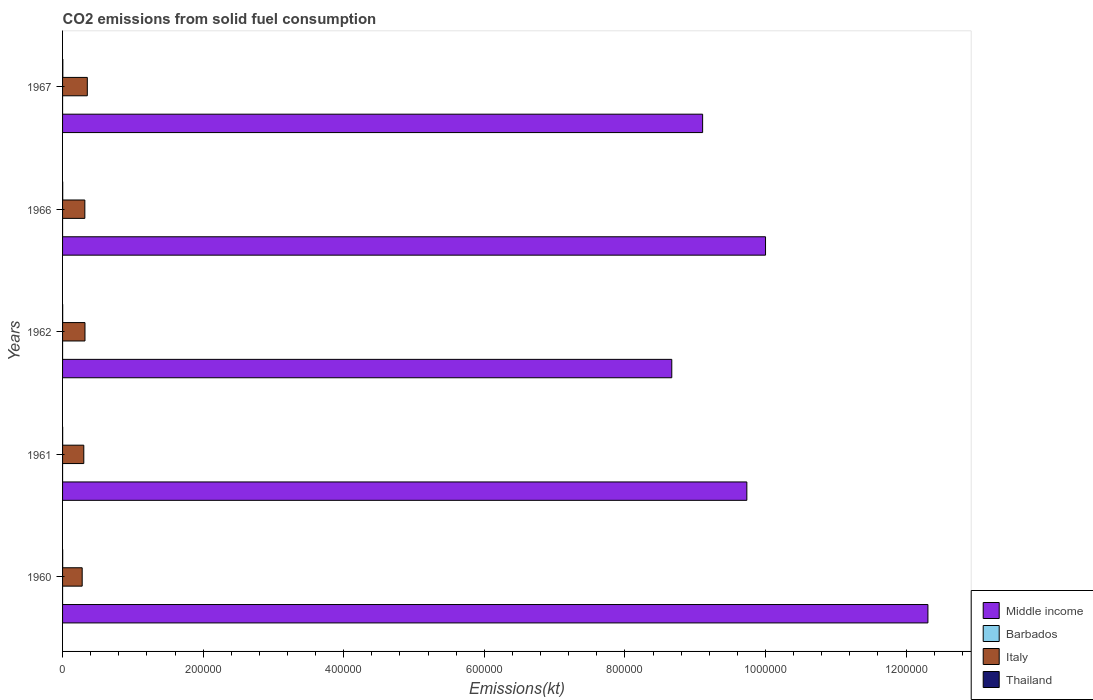How many different coloured bars are there?
Your answer should be compact. 4. Are the number of bars per tick equal to the number of legend labels?
Provide a succinct answer. Yes. Are the number of bars on each tick of the Y-axis equal?
Your answer should be compact. Yes. How many bars are there on the 5th tick from the bottom?
Provide a short and direct response. 4. In how many cases, is the number of bars for a given year not equal to the number of legend labels?
Provide a succinct answer. 0. What is the amount of CO2 emitted in Barbados in 1961?
Provide a succinct answer. 3.67. Across all years, what is the maximum amount of CO2 emitted in Italy?
Your answer should be very brief. 3.52e+04. Across all years, what is the minimum amount of CO2 emitted in Barbados?
Your answer should be very brief. 3.67. In which year was the amount of CO2 emitted in Thailand maximum?
Your answer should be very brief. 1967. In which year was the amount of CO2 emitted in Thailand minimum?
Your answer should be compact. 1961. What is the total amount of CO2 emitted in Middle income in the graph?
Offer a terse response. 4.98e+06. What is the difference between the amount of CO2 emitted in Italy in 1962 and that in 1966?
Make the answer very short. 201.69. What is the difference between the amount of CO2 emitted in Barbados in 1966 and the amount of CO2 emitted in Thailand in 1961?
Provide a short and direct response. -117.34. What is the average amount of CO2 emitted in Italy per year?
Your answer should be compact. 3.14e+04. In the year 1967, what is the difference between the amount of CO2 emitted in Middle income and amount of CO2 emitted in Thailand?
Your answer should be very brief. 9.10e+05. What is the ratio of the amount of CO2 emitted in Thailand in 1962 to that in 1966?
Offer a very short reply. 0.77. Is the amount of CO2 emitted in Middle income in 1961 less than that in 1966?
Keep it short and to the point. Yes. Is the difference between the amount of CO2 emitted in Middle income in 1961 and 1962 greater than the difference between the amount of CO2 emitted in Thailand in 1961 and 1962?
Ensure brevity in your answer.  Yes. What is the difference between the highest and the second highest amount of CO2 emitted in Italy?
Make the answer very short. 3311.3. What is the difference between the highest and the lowest amount of CO2 emitted in Middle income?
Your response must be concise. 3.64e+05. In how many years, is the amount of CO2 emitted in Barbados greater than the average amount of CO2 emitted in Barbados taken over all years?
Your answer should be compact. 0. Is the sum of the amount of CO2 emitted in Italy in 1960 and 1966 greater than the maximum amount of CO2 emitted in Barbados across all years?
Give a very brief answer. Yes. Is it the case that in every year, the sum of the amount of CO2 emitted in Barbados and amount of CO2 emitted in Thailand is greater than the sum of amount of CO2 emitted in Italy and amount of CO2 emitted in Middle income?
Your response must be concise. No. What does the 3rd bar from the top in 1960 represents?
Your answer should be compact. Barbados. What does the 4th bar from the bottom in 1967 represents?
Offer a very short reply. Thailand. Is it the case that in every year, the sum of the amount of CO2 emitted in Italy and amount of CO2 emitted in Middle income is greater than the amount of CO2 emitted in Barbados?
Ensure brevity in your answer.  Yes. Are the values on the major ticks of X-axis written in scientific E-notation?
Provide a succinct answer. No. Does the graph contain grids?
Offer a terse response. No. Where does the legend appear in the graph?
Give a very brief answer. Bottom right. How many legend labels are there?
Ensure brevity in your answer.  4. What is the title of the graph?
Offer a terse response. CO2 emissions from solid fuel consumption. Does "Central Europe" appear as one of the legend labels in the graph?
Offer a terse response. No. What is the label or title of the X-axis?
Give a very brief answer. Emissions(kt). What is the Emissions(kt) of Middle income in 1960?
Your answer should be very brief. 1.23e+06. What is the Emissions(kt) in Barbados in 1960?
Provide a short and direct response. 3.67. What is the Emissions(kt) in Italy in 1960?
Offer a terse response. 2.79e+04. What is the Emissions(kt) in Thailand in 1960?
Ensure brevity in your answer.  146.68. What is the Emissions(kt) of Middle income in 1961?
Offer a terse response. 9.74e+05. What is the Emissions(kt) of Barbados in 1961?
Keep it short and to the point. 3.67. What is the Emissions(kt) in Italy in 1961?
Provide a succinct answer. 3.02e+04. What is the Emissions(kt) in Thailand in 1961?
Offer a very short reply. 121.01. What is the Emissions(kt) of Middle income in 1962?
Keep it short and to the point. 8.67e+05. What is the Emissions(kt) in Barbados in 1962?
Make the answer very short. 3.67. What is the Emissions(kt) in Italy in 1962?
Your answer should be very brief. 3.19e+04. What is the Emissions(kt) of Thailand in 1962?
Offer a terse response. 150.35. What is the Emissions(kt) of Middle income in 1966?
Keep it short and to the point. 1.00e+06. What is the Emissions(kt) of Barbados in 1966?
Your response must be concise. 3.67. What is the Emissions(kt) in Italy in 1966?
Keep it short and to the point. 3.17e+04. What is the Emissions(kt) in Thailand in 1966?
Offer a terse response. 194.35. What is the Emissions(kt) of Middle income in 1967?
Ensure brevity in your answer.  9.11e+05. What is the Emissions(kt) of Barbados in 1967?
Your answer should be compact. 3.67. What is the Emissions(kt) of Italy in 1967?
Your answer should be compact. 3.52e+04. What is the Emissions(kt) of Thailand in 1967?
Offer a very short reply. 374.03. Across all years, what is the maximum Emissions(kt) of Middle income?
Provide a short and direct response. 1.23e+06. Across all years, what is the maximum Emissions(kt) in Barbados?
Keep it short and to the point. 3.67. Across all years, what is the maximum Emissions(kt) of Italy?
Your response must be concise. 3.52e+04. Across all years, what is the maximum Emissions(kt) in Thailand?
Make the answer very short. 374.03. Across all years, what is the minimum Emissions(kt) in Middle income?
Offer a terse response. 8.67e+05. Across all years, what is the minimum Emissions(kt) of Barbados?
Offer a terse response. 3.67. Across all years, what is the minimum Emissions(kt) of Italy?
Offer a terse response. 2.79e+04. Across all years, what is the minimum Emissions(kt) of Thailand?
Make the answer very short. 121.01. What is the total Emissions(kt) of Middle income in the graph?
Provide a succinct answer. 4.98e+06. What is the total Emissions(kt) of Barbados in the graph?
Provide a short and direct response. 18.34. What is the total Emissions(kt) of Italy in the graph?
Make the answer very short. 1.57e+05. What is the total Emissions(kt) of Thailand in the graph?
Keep it short and to the point. 986.42. What is the difference between the Emissions(kt) of Middle income in 1960 and that in 1961?
Your answer should be compact. 2.58e+05. What is the difference between the Emissions(kt) in Italy in 1960 and that in 1961?
Provide a short and direct response. -2288.21. What is the difference between the Emissions(kt) of Thailand in 1960 and that in 1961?
Your answer should be very brief. 25.67. What is the difference between the Emissions(kt) in Middle income in 1960 and that in 1962?
Your answer should be compact. 3.64e+05. What is the difference between the Emissions(kt) of Barbados in 1960 and that in 1962?
Your response must be concise. 0. What is the difference between the Emissions(kt) of Italy in 1960 and that in 1962?
Give a very brief answer. -3993.36. What is the difference between the Emissions(kt) of Thailand in 1960 and that in 1962?
Your response must be concise. -3.67. What is the difference between the Emissions(kt) of Middle income in 1960 and that in 1966?
Offer a terse response. 2.31e+05. What is the difference between the Emissions(kt) of Barbados in 1960 and that in 1966?
Your answer should be very brief. 0. What is the difference between the Emissions(kt) in Italy in 1960 and that in 1966?
Offer a terse response. -3791.68. What is the difference between the Emissions(kt) of Thailand in 1960 and that in 1966?
Your answer should be compact. -47.67. What is the difference between the Emissions(kt) in Middle income in 1960 and that in 1967?
Provide a succinct answer. 3.21e+05. What is the difference between the Emissions(kt) in Barbados in 1960 and that in 1967?
Your response must be concise. 0. What is the difference between the Emissions(kt) in Italy in 1960 and that in 1967?
Ensure brevity in your answer.  -7304.66. What is the difference between the Emissions(kt) in Thailand in 1960 and that in 1967?
Your answer should be very brief. -227.35. What is the difference between the Emissions(kt) of Middle income in 1961 and that in 1962?
Your response must be concise. 1.07e+05. What is the difference between the Emissions(kt) of Italy in 1961 and that in 1962?
Keep it short and to the point. -1705.15. What is the difference between the Emissions(kt) of Thailand in 1961 and that in 1962?
Ensure brevity in your answer.  -29.34. What is the difference between the Emissions(kt) of Middle income in 1961 and that in 1966?
Ensure brevity in your answer.  -2.66e+04. What is the difference between the Emissions(kt) of Barbados in 1961 and that in 1966?
Ensure brevity in your answer.  0. What is the difference between the Emissions(kt) in Italy in 1961 and that in 1966?
Ensure brevity in your answer.  -1503.47. What is the difference between the Emissions(kt) in Thailand in 1961 and that in 1966?
Provide a short and direct response. -73.34. What is the difference between the Emissions(kt) in Middle income in 1961 and that in 1967?
Provide a succinct answer. 6.29e+04. What is the difference between the Emissions(kt) in Barbados in 1961 and that in 1967?
Provide a short and direct response. 0. What is the difference between the Emissions(kt) in Italy in 1961 and that in 1967?
Your answer should be very brief. -5016.46. What is the difference between the Emissions(kt) of Thailand in 1961 and that in 1967?
Make the answer very short. -253.02. What is the difference between the Emissions(kt) in Middle income in 1962 and that in 1966?
Give a very brief answer. -1.33e+05. What is the difference between the Emissions(kt) of Italy in 1962 and that in 1966?
Offer a terse response. 201.69. What is the difference between the Emissions(kt) of Thailand in 1962 and that in 1966?
Provide a short and direct response. -44. What is the difference between the Emissions(kt) of Middle income in 1962 and that in 1967?
Your response must be concise. -4.39e+04. What is the difference between the Emissions(kt) in Barbados in 1962 and that in 1967?
Offer a terse response. 0. What is the difference between the Emissions(kt) of Italy in 1962 and that in 1967?
Your answer should be very brief. -3311.3. What is the difference between the Emissions(kt) in Thailand in 1962 and that in 1967?
Give a very brief answer. -223.69. What is the difference between the Emissions(kt) of Middle income in 1966 and that in 1967?
Your response must be concise. 8.95e+04. What is the difference between the Emissions(kt) in Italy in 1966 and that in 1967?
Offer a very short reply. -3512.99. What is the difference between the Emissions(kt) of Thailand in 1966 and that in 1967?
Provide a short and direct response. -179.68. What is the difference between the Emissions(kt) in Middle income in 1960 and the Emissions(kt) in Barbados in 1961?
Ensure brevity in your answer.  1.23e+06. What is the difference between the Emissions(kt) of Middle income in 1960 and the Emissions(kt) of Italy in 1961?
Make the answer very short. 1.20e+06. What is the difference between the Emissions(kt) in Middle income in 1960 and the Emissions(kt) in Thailand in 1961?
Give a very brief answer. 1.23e+06. What is the difference between the Emissions(kt) in Barbados in 1960 and the Emissions(kt) in Italy in 1961?
Give a very brief answer. -3.02e+04. What is the difference between the Emissions(kt) of Barbados in 1960 and the Emissions(kt) of Thailand in 1961?
Make the answer very short. -117.34. What is the difference between the Emissions(kt) in Italy in 1960 and the Emissions(kt) in Thailand in 1961?
Make the answer very short. 2.78e+04. What is the difference between the Emissions(kt) in Middle income in 1960 and the Emissions(kt) in Barbados in 1962?
Your response must be concise. 1.23e+06. What is the difference between the Emissions(kt) of Middle income in 1960 and the Emissions(kt) of Italy in 1962?
Ensure brevity in your answer.  1.20e+06. What is the difference between the Emissions(kt) in Middle income in 1960 and the Emissions(kt) in Thailand in 1962?
Offer a very short reply. 1.23e+06. What is the difference between the Emissions(kt) in Barbados in 1960 and the Emissions(kt) in Italy in 1962?
Your answer should be very brief. -3.19e+04. What is the difference between the Emissions(kt) in Barbados in 1960 and the Emissions(kt) in Thailand in 1962?
Make the answer very short. -146.68. What is the difference between the Emissions(kt) of Italy in 1960 and the Emissions(kt) of Thailand in 1962?
Offer a terse response. 2.78e+04. What is the difference between the Emissions(kt) in Middle income in 1960 and the Emissions(kt) in Barbados in 1966?
Offer a terse response. 1.23e+06. What is the difference between the Emissions(kt) in Middle income in 1960 and the Emissions(kt) in Italy in 1966?
Keep it short and to the point. 1.20e+06. What is the difference between the Emissions(kt) in Middle income in 1960 and the Emissions(kt) in Thailand in 1966?
Keep it short and to the point. 1.23e+06. What is the difference between the Emissions(kt) in Barbados in 1960 and the Emissions(kt) in Italy in 1966?
Provide a short and direct response. -3.17e+04. What is the difference between the Emissions(kt) of Barbados in 1960 and the Emissions(kt) of Thailand in 1966?
Provide a succinct answer. -190.68. What is the difference between the Emissions(kt) of Italy in 1960 and the Emissions(kt) of Thailand in 1966?
Your answer should be compact. 2.77e+04. What is the difference between the Emissions(kt) of Middle income in 1960 and the Emissions(kt) of Barbados in 1967?
Make the answer very short. 1.23e+06. What is the difference between the Emissions(kt) of Middle income in 1960 and the Emissions(kt) of Italy in 1967?
Make the answer very short. 1.20e+06. What is the difference between the Emissions(kt) of Middle income in 1960 and the Emissions(kt) of Thailand in 1967?
Provide a succinct answer. 1.23e+06. What is the difference between the Emissions(kt) in Barbados in 1960 and the Emissions(kt) in Italy in 1967?
Ensure brevity in your answer.  -3.52e+04. What is the difference between the Emissions(kt) in Barbados in 1960 and the Emissions(kt) in Thailand in 1967?
Offer a very short reply. -370.37. What is the difference between the Emissions(kt) of Italy in 1960 and the Emissions(kt) of Thailand in 1967?
Keep it short and to the point. 2.75e+04. What is the difference between the Emissions(kt) of Middle income in 1961 and the Emissions(kt) of Barbados in 1962?
Provide a short and direct response. 9.74e+05. What is the difference between the Emissions(kt) of Middle income in 1961 and the Emissions(kt) of Italy in 1962?
Offer a very short reply. 9.42e+05. What is the difference between the Emissions(kt) in Middle income in 1961 and the Emissions(kt) in Thailand in 1962?
Keep it short and to the point. 9.73e+05. What is the difference between the Emissions(kt) in Barbados in 1961 and the Emissions(kt) in Italy in 1962?
Your answer should be compact. -3.19e+04. What is the difference between the Emissions(kt) of Barbados in 1961 and the Emissions(kt) of Thailand in 1962?
Keep it short and to the point. -146.68. What is the difference between the Emissions(kt) in Italy in 1961 and the Emissions(kt) in Thailand in 1962?
Your response must be concise. 3.00e+04. What is the difference between the Emissions(kt) of Middle income in 1961 and the Emissions(kt) of Barbados in 1966?
Your response must be concise. 9.74e+05. What is the difference between the Emissions(kt) in Middle income in 1961 and the Emissions(kt) in Italy in 1966?
Your answer should be very brief. 9.42e+05. What is the difference between the Emissions(kt) of Middle income in 1961 and the Emissions(kt) of Thailand in 1966?
Your answer should be very brief. 9.73e+05. What is the difference between the Emissions(kt) of Barbados in 1961 and the Emissions(kt) of Italy in 1966?
Offer a terse response. -3.17e+04. What is the difference between the Emissions(kt) of Barbados in 1961 and the Emissions(kt) of Thailand in 1966?
Offer a very short reply. -190.68. What is the difference between the Emissions(kt) of Italy in 1961 and the Emissions(kt) of Thailand in 1966?
Offer a very short reply. 3.00e+04. What is the difference between the Emissions(kt) in Middle income in 1961 and the Emissions(kt) in Barbados in 1967?
Give a very brief answer. 9.74e+05. What is the difference between the Emissions(kt) in Middle income in 1961 and the Emissions(kt) in Italy in 1967?
Make the answer very short. 9.38e+05. What is the difference between the Emissions(kt) of Middle income in 1961 and the Emissions(kt) of Thailand in 1967?
Make the answer very short. 9.73e+05. What is the difference between the Emissions(kt) of Barbados in 1961 and the Emissions(kt) of Italy in 1967?
Your answer should be very brief. -3.52e+04. What is the difference between the Emissions(kt) of Barbados in 1961 and the Emissions(kt) of Thailand in 1967?
Give a very brief answer. -370.37. What is the difference between the Emissions(kt) of Italy in 1961 and the Emissions(kt) of Thailand in 1967?
Provide a short and direct response. 2.98e+04. What is the difference between the Emissions(kt) in Middle income in 1962 and the Emissions(kt) in Barbados in 1966?
Your response must be concise. 8.67e+05. What is the difference between the Emissions(kt) of Middle income in 1962 and the Emissions(kt) of Italy in 1966?
Offer a terse response. 8.35e+05. What is the difference between the Emissions(kt) in Middle income in 1962 and the Emissions(kt) in Thailand in 1966?
Your response must be concise. 8.67e+05. What is the difference between the Emissions(kt) in Barbados in 1962 and the Emissions(kt) in Italy in 1966?
Your answer should be very brief. -3.17e+04. What is the difference between the Emissions(kt) of Barbados in 1962 and the Emissions(kt) of Thailand in 1966?
Ensure brevity in your answer.  -190.68. What is the difference between the Emissions(kt) of Italy in 1962 and the Emissions(kt) of Thailand in 1966?
Your response must be concise. 3.17e+04. What is the difference between the Emissions(kt) in Middle income in 1962 and the Emissions(kt) in Barbados in 1967?
Offer a very short reply. 8.67e+05. What is the difference between the Emissions(kt) of Middle income in 1962 and the Emissions(kt) of Italy in 1967?
Your answer should be very brief. 8.32e+05. What is the difference between the Emissions(kt) in Middle income in 1962 and the Emissions(kt) in Thailand in 1967?
Keep it short and to the point. 8.66e+05. What is the difference between the Emissions(kt) in Barbados in 1962 and the Emissions(kt) in Italy in 1967?
Keep it short and to the point. -3.52e+04. What is the difference between the Emissions(kt) of Barbados in 1962 and the Emissions(kt) of Thailand in 1967?
Your answer should be compact. -370.37. What is the difference between the Emissions(kt) of Italy in 1962 and the Emissions(kt) of Thailand in 1967?
Provide a succinct answer. 3.15e+04. What is the difference between the Emissions(kt) of Middle income in 1966 and the Emissions(kt) of Barbados in 1967?
Provide a succinct answer. 1.00e+06. What is the difference between the Emissions(kt) of Middle income in 1966 and the Emissions(kt) of Italy in 1967?
Ensure brevity in your answer.  9.65e+05. What is the difference between the Emissions(kt) of Middle income in 1966 and the Emissions(kt) of Thailand in 1967?
Provide a short and direct response. 1.00e+06. What is the difference between the Emissions(kt) in Barbados in 1966 and the Emissions(kt) in Italy in 1967?
Your answer should be compact. -3.52e+04. What is the difference between the Emissions(kt) of Barbados in 1966 and the Emissions(kt) of Thailand in 1967?
Your response must be concise. -370.37. What is the difference between the Emissions(kt) of Italy in 1966 and the Emissions(kt) of Thailand in 1967?
Offer a terse response. 3.13e+04. What is the average Emissions(kt) in Middle income per year?
Make the answer very short. 9.96e+05. What is the average Emissions(kt) in Barbados per year?
Provide a short and direct response. 3.67. What is the average Emissions(kt) of Italy per year?
Give a very brief answer. 3.14e+04. What is the average Emissions(kt) in Thailand per year?
Make the answer very short. 197.28. In the year 1960, what is the difference between the Emissions(kt) of Middle income and Emissions(kt) of Barbados?
Provide a short and direct response. 1.23e+06. In the year 1960, what is the difference between the Emissions(kt) of Middle income and Emissions(kt) of Italy?
Offer a very short reply. 1.20e+06. In the year 1960, what is the difference between the Emissions(kt) in Middle income and Emissions(kt) in Thailand?
Offer a terse response. 1.23e+06. In the year 1960, what is the difference between the Emissions(kt) of Barbados and Emissions(kt) of Italy?
Offer a very short reply. -2.79e+04. In the year 1960, what is the difference between the Emissions(kt) of Barbados and Emissions(kt) of Thailand?
Provide a short and direct response. -143.01. In the year 1960, what is the difference between the Emissions(kt) of Italy and Emissions(kt) of Thailand?
Keep it short and to the point. 2.78e+04. In the year 1961, what is the difference between the Emissions(kt) of Middle income and Emissions(kt) of Barbados?
Your answer should be very brief. 9.74e+05. In the year 1961, what is the difference between the Emissions(kt) of Middle income and Emissions(kt) of Italy?
Your answer should be very brief. 9.43e+05. In the year 1961, what is the difference between the Emissions(kt) in Middle income and Emissions(kt) in Thailand?
Offer a very short reply. 9.73e+05. In the year 1961, what is the difference between the Emissions(kt) in Barbados and Emissions(kt) in Italy?
Give a very brief answer. -3.02e+04. In the year 1961, what is the difference between the Emissions(kt) in Barbados and Emissions(kt) in Thailand?
Provide a short and direct response. -117.34. In the year 1961, what is the difference between the Emissions(kt) of Italy and Emissions(kt) of Thailand?
Offer a very short reply. 3.01e+04. In the year 1962, what is the difference between the Emissions(kt) of Middle income and Emissions(kt) of Barbados?
Keep it short and to the point. 8.67e+05. In the year 1962, what is the difference between the Emissions(kt) of Middle income and Emissions(kt) of Italy?
Provide a short and direct response. 8.35e+05. In the year 1962, what is the difference between the Emissions(kt) in Middle income and Emissions(kt) in Thailand?
Give a very brief answer. 8.67e+05. In the year 1962, what is the difference between the Emissions(kt) in Barbados and Emissions(kt) in Italy?
Your answer should be very brief. -3.19e+04. In the year 1962, what is the difference between the Emissions(kt) of Barbados and Emissions(kt) of Thailand?
Offer a terse response. -146.68. In the year 1962, what is the difference between the Emissions(kt) of Italy and Emissions(kt) of Thailand?
Provide a short and direct response. 3.17e+04. In the year 1966, what is the difference between the Emissions(kt) in Middle income and Emissions(kt) in Barbados?
Keep it short and to the point. 1.00e+06. In the year 1966, what is the difference between the Emissions(kt) in Middle income and Emissions(kt) in Italy?
Provide a succinct answer. 9.68e+05. In the year 1966, what is the difference between the Emissions(kt) of Middle income and Emissions(kt) of Thailand?
Your response must be concise. 1.00e+06. In the year 1966, what is the difference between the Emissions(kt) in Barbados and Emissions(kt) in Italy?
Your answer should be very brief. -3.17e+04. In the year 1966, what is the difference between the Emissions(kt) in Barbados and Emissions(kt) in Thailand?
Keep it short and to the point. -190.68. In the year 1966, what is the difference between the Emissions(kt) in Italy and Emissions(kt) in Thailand?
Offer a terse response. 3.15e+04. In the year 1967, what is the difference between the Emissions(kt) of Middle income and Emissions(kt) of Barbados?
Keep it short and to the point. 9.11e+05. In the year 1967, what is the difference between the Emissions(kt) in Middle income and Emissions(kt) in Italy?
Keep it short and to the point. 8.75e+05. In the year 1967, what is the difference between the Emissions(kt) in Middle income and Emissions(kt) in Thailand?
Your answer should be compact. 9.10e+05. In the year 1967, what is the difference between the Emissions(kt) of Barbados and Emissions(kt) of Italy?
Provide a short and direct response. -3.52e+04. In the year 1967, what is the difference between the Emissions(kt) of Barbados and Emissions(kt) of Thailand?
Give a very brief answer. -370.37. In the year 1967, what is the difference between the Emissions(kt) of Italy and Emissions(kt) of Thailand?
Your answer should be compact. 3.48e+04. What is the ratio of the Emissions(kt) in Middle income in 1960 to that in 1961?
Ensure brevity in your answer.  1.26. What is the ratio of the Emissions(kt) in Italy in 1960 to that in 1961?
Your answer should be compact. 0.92. What is the ratio of the Emissions(kt) of Thailand in 1960 to that in 1961?
Ensure brevity in your answer.  1.21. What is the ratio of the Emissions(kt) in Middle income in 1960 to that in 1962?
Provide a succinct answer. 1.42. What is the ratio of the Emissions(kt) of Italy in 1960 to that in 1962?
Provide a short and direct response. 0.87. What is the ratio of the Emissions(kt) in Thailand in 1960 to that in 1962?
Make the answer very short. 0.98. What is the ratio of the Emissions(kt) of Middle income in 1960 to that in 1966?
Your answer should be very brief. 1.23. What is the ratio of the Emissions(kt) of Italy in 1960 to that in 1966?
Give a very brief answer. 0.88. What is the ratio of the Emissions(kt) of Thailand in 1960 to that in 1966?
Your response must be concise. 0.75. What is the ratio of the Emissions(kt) of Middle income in 1960 to that in 1967?
Your answer should be very brief. 1.35. What is the ratio of the Emissions(kt) of Barbados in 1960 to that in 1967?
Provide a short and direct response. 1. What is the ratio of the Emissions(kt) of Italy in 1960 to that in 1967?
Provide a short and direct response. 0.79. What is the ratio of the Emissions(kt) in Thailand in 1960 to that in 1967?
Give a very brief answer. 0.39. What is the ratio of the Emissions(kt) in Middle income in 1961 to that in 1962?
Give a very brief answer. 1.12. What is the ratio of the Emissions(kt) of Barbados in 1961 to that in 1962?
Offer a terse response. 1. What is the ratio of the Emissions(kt) in Italy in 1961 to that in 1962?
Keep it short and to the point. 0.95. What is the ratio of the Emissions(kt) of Thailand in 1961 to that in 1962?
Your response must be concise. 0.8. What is the ratio of the Emissions(kt) of Middle income in 1961 to that in 1966?
Give a very brief answer. 0.97. What is the ratio of the Emissions(kt) in Italy in 1961 to that in 1966?
Ensure brevity in your answer.  0.95. What is the ratio of the Emissions(kt) in Thailand in 1961 to that in 1966?
Give a very brief answer. 0.62. What is the ratio of the Emissions(kt) in Middle income in 1961 to that in 1967?
Your response must be concise. 1.07. What is the ratio of the Emissions(kt) of Italy in 1961 to that in 1967?
Offer a very short reply. 0.86. What is the ratio of the Emissions(kt) in Thailand in 1961 to that in 1967?
Your response must be concise. 0.32. What is the ratio of the Emissions(kt) of Middle income in 1962 to that in 1966?
Provide a succinct answer. 0.87. What is the ratio of the Emissions(kt) in Barbados in 1962 to that in 1966?
Offer a very short reply. 1. What is the ratio of the Emissions(kt) in Italy in 1962 to that in 1966?
Your answer should be very brief. 1.01. What is the ratio of the Emissions(kt) in Thailand in 1962 to that in 1966?
Provide a succinct answer. 0.77. What is the ratio of the Emissions(kt) in Middle income in 1962 to that in 1967?
Offer a very short reply. 0.95. What is the ratio of the Emissions(kt) in Italy in 1962 to that in 1967?
Your answer should be compact. 0.91. What is the ratio of the Emissions(kt) of Thailand in 1962 to that in 1967?
Make the answer very short. 0.4. What is the ratio of the Emissions(kt) of Middle income in 1966 to that in 1967?
Provide a short and direct response. 1.1. What is the ratio of the Emissions(kt) of Italy in 1966 to that in 1967?
Provide a succinct answer. 0.9. What is the ratio of the Emissions(kt) in Thailand in 1966 to that in 1967?
Your response must be concise. 0.52. What is the difference between the highest and the second highest Emissions(kt) of Middle income?
Offer a terse response. 2.31e+05. What is the difference between the highest and the second highest Emissions(kt) of Barbados?
Give a very brief answer. 0. What is the difference between the highest and the second highest Emissions(kt) of Italy?
Your response must be concise. 3311.3. What is the difference between the highest and the second highest Emissions(kt) of Thailand?
Give a very brief answer. 179.68. What is the difference between the highest and the lowest Emissions(kt) of Middle income?
Provide a short and direct response. 3.64e+05. What is the difference between the highest and the lowest Emissions(kt) in Barbados?
Your response must be concise. 0. What is the difference between the highest and the lowest Emissions(kt) in Italy?
Offer a very short reply. 7304.66. What is the difference between the highest and the lowest Emissions(kt) in Thailand?
Your answer should be compact. 253.02. 